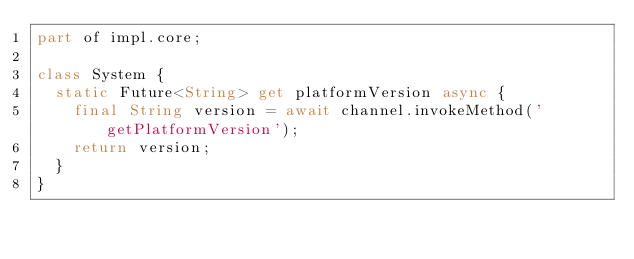Convert code to text. <code><loc_0><loc_0><loc_500><loc_500><_Dart_>part of impl.core;

class System {
  static Future<String> get platformVersion async {
    final String version = await channel.invokeMethod('getPlatformVersion');
    return version;
  }
}
</code> 